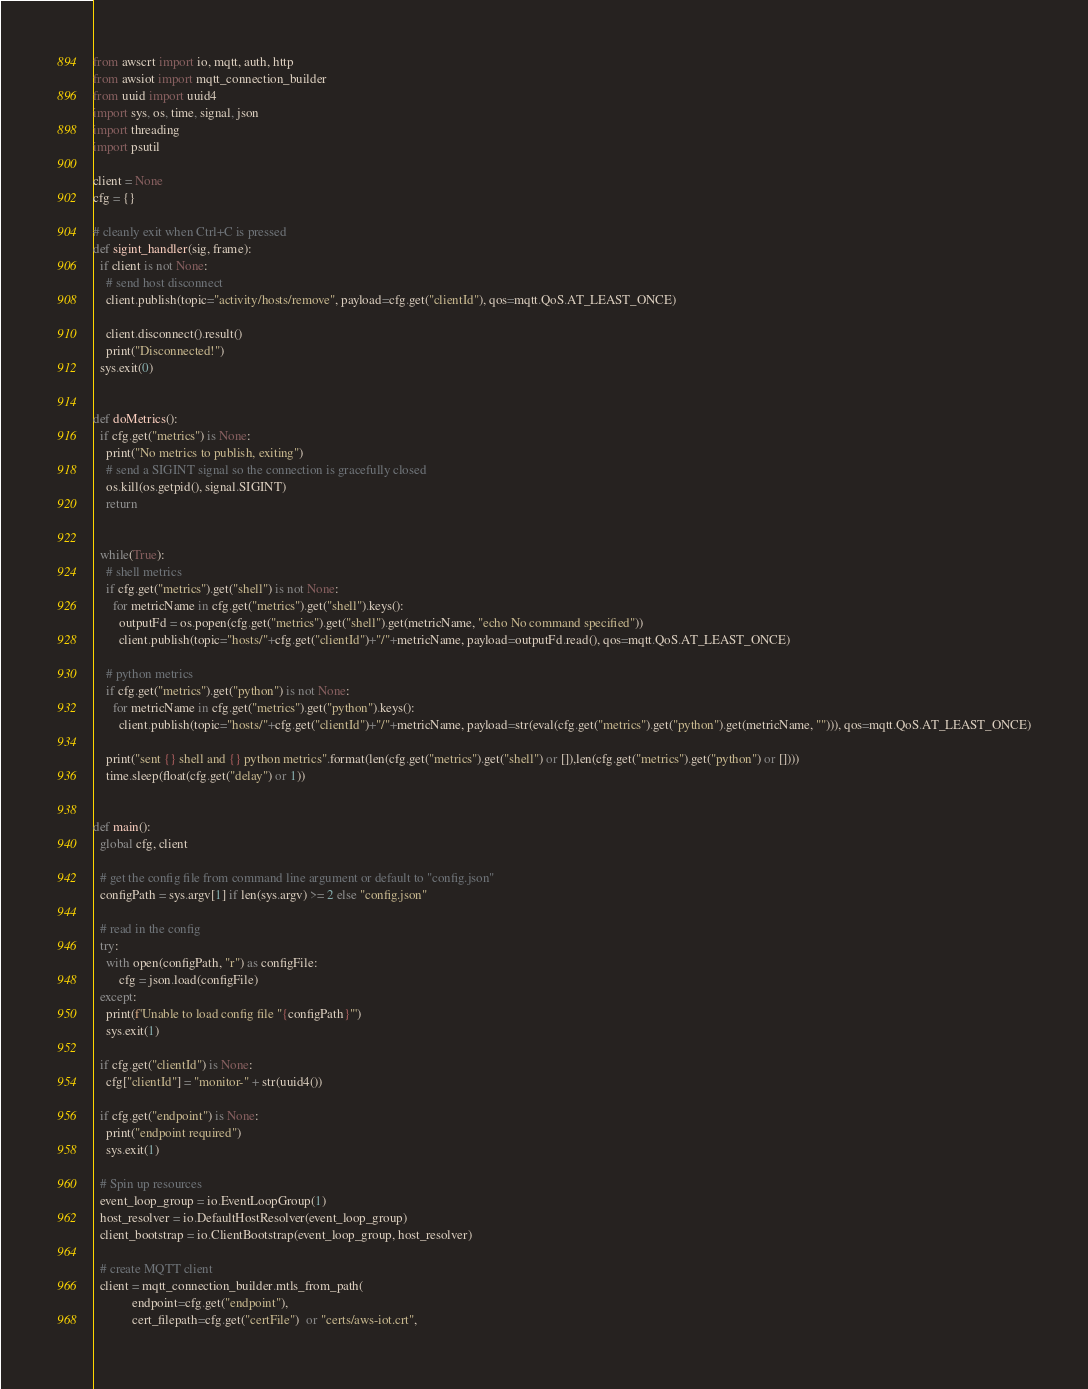Convert code to text. <code><loc_0><loc_0><loc_500><loc_500><_Python_>from awscrt import io, mqtt, auth, http
from awsiot import mqtt_connection_builder
from uuid import uuid4
import sys, os, time, signal, json
import threading
import psutil

client = None
cfg = {}

# cleanly exit when Ctrl+C is pressed
def sigint_handler(sig, frame):
  if client is not None:
    # send host disconnect
    client.publish(topic="activity/hosts/remove", payload=cfg.get("clientId"), qos=mqtt.QoS.AT_LEAST_ONCE)

    client.disconnect().result()
    print("Disconnected!")
  sys.exit(0)


def doMetrics():
  if cfg.get("metrics") is None:
    print("No metrics to publish, exiting")
    # send a SIGINT signal so the connection is gracefully closed
    os.kill(os.getpid(), signal.SIGINT)
    return


  while(True):
    # shell metrics
    if cfg.get("metrics").get("shell") is not None:
      for metricName in cfg.get("metrics").get("shell").keys():
        outputFd = os.popen(cfg.get("metrics").get("shell").get(metricName, "echo No command specified"))
        client.publish(topic="hosts/"+cfg.get("clientId")+"/"+metricName, payload=outputFd.read(), qos=mqtt.QoS.AT_LEAST_ONCE)

    # python metrics
    if cfg.get("metrics").get("python") is not None:
      for metricName in cfg.get("metrics").get("python").keys():
        client.publish(topic="hosts/"+cfg.get("clientId")+"/"+metricName, payload=str(eval(cfg.get("metrics").get("python").get(metricName, ""))), qos=mqtt.QoS.AT_LEAST_ONCE)

    print("sent {} shell and {} python metrics".format(len(cfg.get("metrics").get("shell") or []),len(cfg.get("metrics").get("python") or [])))
    time.sleep(float(cfg.get("delay") or 1))


def main():
  global cfg, client

  # get the config file from command line argument or default to "config.json"
  configPath = sys.argv[1] if len(sys.argv) >= 2 else "config.json"

  # read in the config
  try:
    with open(configPath, "r") as configFile:
        cfg = json.load(configFile)
  except:
    print(f'Unable to load config file "{configPath}"')
    sys.exit(1)

  if cfg.get("clientId") is None:
    cfg["clientId"] = "monitor-" + str(uuid4())

  if cfg.get("endpoint") is None:
    print("endpoint required")
    sys.exit(1)

  # Spin up resources
  event_loop_group = io.EventLoopGroup(1)
  host_resolver = io.DefaultHostResolver(event_loop_group)
  client_bootstrap = io.ClientBootstrap(event_loop_group, host_resolver)

  # create MQTT client
  client = mqtt_connection_builder.mtls_from_path(
            endpoint=cfg.get("endpoint"),
            cert_filepath=cfg.get("certFile")  or "certs/aws-iot.crt",</code> 